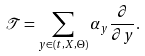<formula> <loc_0><loc_0><loc_500><loc_500>\mathcal { T } = \sum _ { y \in ( t , X , \Theta ) } \alpha _ { y } \frac { \partial } { \partial y } .</formula> 